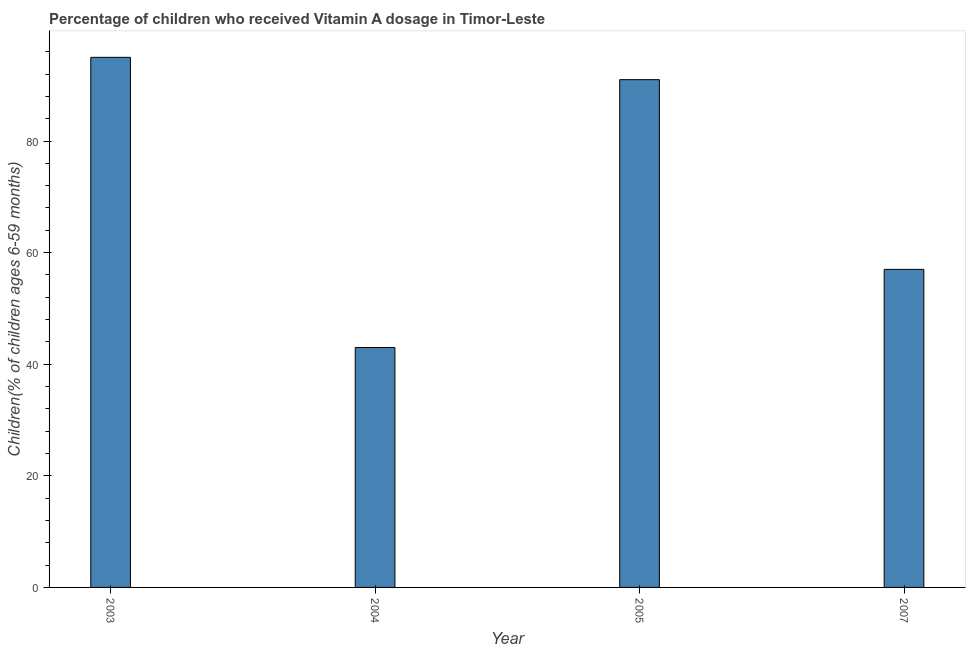Does the graph contain any zero values?
Give a very brief answer. No. What is the title of the graph?
Give a very brief answer. Percentage of children who received Vitamin A dosage in Timor-Leste. What is the label or title of the X-axis?
Your answer should be compact. Year. What is the label or title of the Y-axis?
Keep it short and to the point. Children(% of children ages 6-59 months). What is the vitamin a supplementation coverage rate in 2003?
Offer a terse response. 95. What is the sum of the vitamin a supplementation coverage rate?
Keep it short and to the point. 286. What is the difference between the vitamin a supplementation coverage rate in 2004 and 2007?
Your answer should be compact. -14. What is the average vitamin a supplementation coverage rate per year?
Your answer should be very brief. 71.5. What is the median vitamin a supplementation coverage rate?
Offer a very short reply. 74. What is the ratio of the vitamin a supplementation coverage rate in 2003 to that in 2004?
Make the answer very short. 2.21. What is the difference between the highest and the second highest vitamin a supplementation coverage rate?
Ensure brevity in your answer.  4. How many bars are there?
Provide a short and direct response. 4. How many years are there in the graph?
Make the answer very short. 4. What is the difference between two consecutive major ticks on the Y-axis?
Ensure brevity in your answer.  20. Are the values on the major ticks of Y-axis written in scientific E-notation?
Offer a very short reply. No. What is the Children(% of children ages 6-59 months) of 2003?
Provide a short and direct response. 95. What is the Children(% of children ages 6-59 months) of 2004?
Offer a very short reply. 43. What is the Children(% of children ages 6-59 months) of 2005?
Give a very brief answer. 91. What is the difference between the Children(% of children ages 6-59 months) in 2003 and 2005?
Your answer should be very brief. 4. What is the difference between the Children(% of children ages 6-59 months) in 2004 and 2005?
Your answer should be compact. -48. What is the difference between the Children(% of children ages 6-59 months) in 2005 and 2007?
Keep it short and to the point. 34. What is the ratio of the Children(% of children ages 6-59 months) in 2003 to that in 2004?
Provide a short and direct response. 2.21. What is the ratio of the Children(% of children ages 6-59 months) in 2003 to that in 2005?
Your answer should be compact. 1.04. What is the ratio of the Children(% of children ages 6-59 months) in 2003 to that in 2007?
Ensure brevity in your answer.  1.67. What is the ratio of the Children(% of children ages 6-59 months) in 2004 to that in 2005?
Offer a terse response. 0.47. What is the ratio of the Children(% of children ages 6-59 months) in 2004 to that in 2007?
Offer a very short reply. 0.75. What is the ratio of the Children(% of children ages 6-59 months) in 2005 to that in 2007?
Your answer should be very brief. 1.6. 